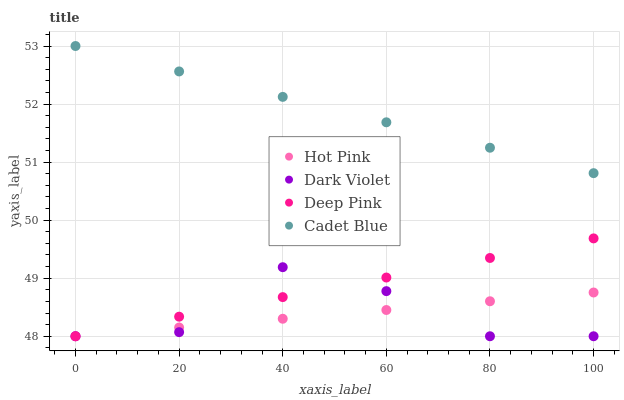Does Hot Pink have the minimum area under the curve?
Answer yes or no. Yes. Does Cadet Blue have the maximum area under the curve?
Answer yes or no. Yes. Does Dark Violet have the minimum area under the curve?
Answer yes or no. No. Does Dark Violet have the maximum area under the curve?
Answer yes or no. No. Is Cadet Blue the smoothest?
Answer yes or no. Yes. Is Dark Violet the roughest?
Answer yes or no. Yes. Is Hot Pink the smoothest?
Answer yes or no. No. Is Hot Pink the roughest?
Answer yes or no. No. Does Hot Pink have the lowest value?
Answer yes or no. Yes. Does Cadet Blue have the highest value?
Answer yes or no. Yes. Does Dark Violet have the highest value?
Answer yes or no. No. Is Hot Pink less than Cadet Blue?
Answer yes or no. Yes. Is Cadet Blue greater than Deep Pink?
Answer yes or no. Yes. Does Dark Violet intersect Deep Pink?
Answer yes or no. Yes. Is Dark Violet less than Deep Pink?
Answer yes or no. No. Is Dark Violet greater than Deep Pink?
Answer yes or no. No. Does Hot Pink intersect Cadet Blue?
Answer yes or no. No. 